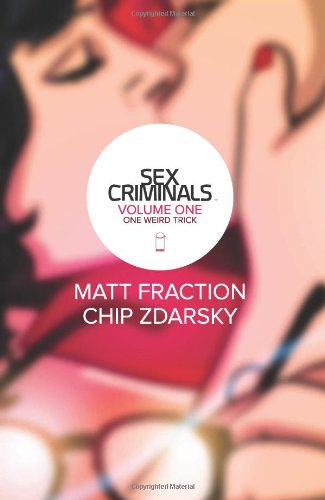Can you describe the artwork style shown on the cover of this book? The artwork on the cover of 'Sex Criminals' uses soft pastel colors with bold, expressive character illustrations. It's stylistic and slightly abstract, aiming to capture the book's unique tone and themes. 